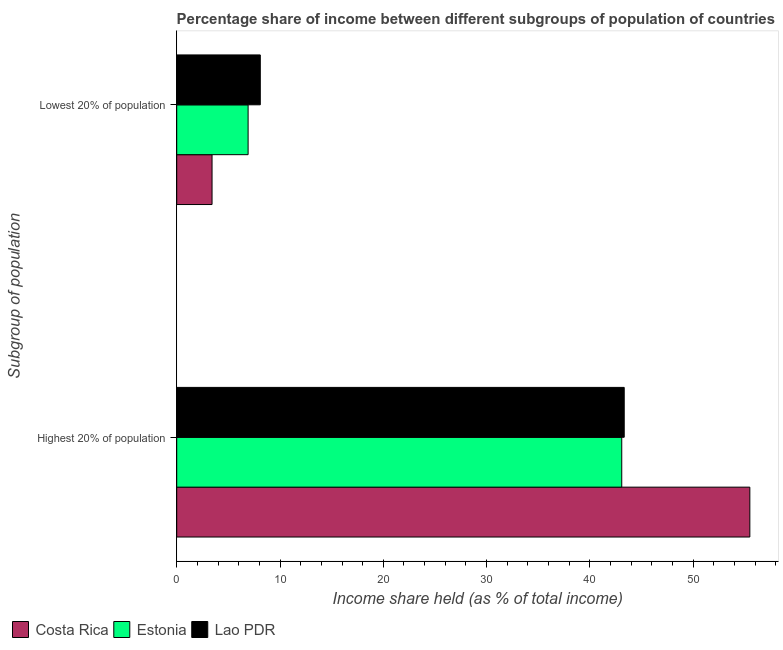Are the number of bars on each tick of the Y-axis equal?
Provide a succinct answer. Yes. How many bars are there on the 1st tick from the top?
Your answer should be compact. 3. What is the label of the 2nd group of bars from the top?
Make the answer very short. Highest 20% of population. What is the income share held by highest 20% of the population in Estonia?
Make the answer very short. 43.08. Across all countries, what is the maximum income share held by highest 20% of the population?
Provide a short and direct response. 55.48. Across all countries, what is the minimum income share held by highest 20% of the population?
Your answer should be very brief. 43.08. In which country was the income share held by highest 20% of the population maximum?
Your answer should be compact. Costa Rica. In which country was the income share held by lowest 20% of the population minimum?
Offer a very short reply. Costa Rica. What is the total income share held by lowest 20% of the population in the graph?
Make the answer very short. 18.42. What is the difference between the income share held by highest 20% of the population in Lao PDR and that in Costa Rica?
Your answer should be very brief. -12.16. What is the difference between the income share held by lowest 20% of the population in Lao PDR and the income share held by highest 20% of the population in Estonia?
Provide a short and direct response. -34.99. What is the average income share held by highest 20% of the population per country?
Your response must be concise. 47.29. What is the difference between the income share held by lowest 20% of the population and income share held by highest 20% of the population in Lao PDR?
Ensure brevity in your answer.  -35.23. In how many countries, is the income share held by highest 20% of the population greater than 48 %?
Give a very brief answer. 1. What is the ratio of the income share held by lowest 20% of the population in Estonia to that in Lao PDR?
Offer a terse response. 0.85. Is the income share held by highest 20% of the population in Lao PDR less than that in Estonia?
Offer a very short reply. No. In how many countries, is the income share held by lowest 20% of the population greater than the average income share held by lowest 20% of the population taken over all countries?
Keep it short and to the point. 2. What does the 1st bar from the top in Highest 20% of population represents?
Provide a succinct answer. Lao PDR. What does the 3rd bar from the bottom in Highest 20% of population represents?
Ensure brevity in your answer.  Lao PDR. How many bars are there?
Offer a terse response. 6. Are all the bars in the graph horizontal?
Your response must be concise. Yes. Are the values on the major ticks of X-axis written in scientific E-notation?
Make the answer very short. No. Does the graph contain any zero values?
Offer a terse response. No. Does the graph contain grids?
Make the answer very short. No. What is the title of the graph?
Give a very brief answer. Percentage share of income between different subgroups of population of countries. Does "Congo (Republic)" appear as one of the legend labels in the graph?
Keep it short and to the point. No. What is the label or title of the X-axis?
Provide a short and direct response. Income share held (as % of total income). What is the label or title of the Y-axis?
Ensure brevity in your answer.  Subgroup of population. What is the Income share held (as % of total income) of Costa Rica in Highest 20% of population?
Give a very brief answer. 55.48. What is the Income share held (as % of total income) in Estonia in Highest 20% of population?
Ensure brevity in your answer.  43.08. What is the Income share held (as % of total income) in Lao PDR in Highest 20% of population?
Your answer should be very brief. 43.32. What is the Income share held (as % of total income) of Costa Rica in Lowest 20% of population?
Provide a succinct answer. 3.42. What is the Income share held (as % of total income) in Estonia in Lowest 20% of population?
Offer a very short reply. 6.91. What is the Income share held (as % of total income) in Lao PDR in Lowest 20% of population?
Provide a short and direct response. 8.09. Across all Subgroup of population, what is the maximum Income share held (as % of total income) of Costa Rica?
Offer a terse response. 55.48. Across all Subgroup of population, what is the maximum Income share held (as % of total income) of Estonia?
Offer a very short reply. 43.08. Across all Subgroup of population, what is the maximum Income share held (as % of total income) of Lao PDR?
Make the answer very short. 43.32. Across all Subgroup of population, what is the minimum Income share held (as % of total income) in Costa Rica?
Your response must be concise. 3.42. Across all Subgroup of population, what is the minimum Income share held (as % of total income) in Estonia?
Ensure brevity in your answer.  6.91. Across all Subgroup of population, what is the minimum Income share held (as % of total income) of Lao PDR?
Keep it short and to the point. 8.09. What is the total Income share held (as % of total income) in Costa Rica in the graph?
Your answer should be very brief. 58.9. What is the total Income share held (as % of total income) in Estonia in the graph?
Your response must be concise. 49.99. What is the total Income share held (as % of total income) in Lao PDR in the graph?
Your response must be concise. 51.41. What is the difference between the Income share held (as % of total income) of Costa Rica in Highest 20% of population and that in Lowest 20% of population?
Give a very brief answer. 52.06. What is the difference between the Income share held (as % of total income) in Estonia in Highest 20% of population and that in Lowest 20% of population?
Offer a very short reply. 36.17. What is the difference between the Income share held (as % of total income) in Lao PDR in Highest 20% of population and that in Lowest 20% of population?
Your answer should be very brief. 35.23. What is the difference between the Income share held (as % of total income) of Costa Rica in Highest 20% of population and the Income share held (as % of total income) of Estonia in Lowest 20% of population?
Your answer should be very brief. 48.57. What is the difference between the Income share held (as % of total income) in Costa Rica in Highest 20% of population and the Income share held (as % of total income) in Lao PDR in Lowest 20% of population?
Offer a very short reply. 47.39. What is the difference between the Income share held (as % of total income) of Estonia in Highest 20% of population and the Income share held (as % of total income) of Lao PDR in Lowest 20% of population?
Offer a very short reply. 34.99. What is the average Income share held (as % of total income) in Costa Rica per Subgroup of population?
Ensure brevity in your answer.  29.45. What is the average Income share held (as % of total income) in Estonia per Subgroup of population?
Your response must be concise. 25. What is the average Income share held (as % of total income) in Lao PDR per Subgroup of population?
Provide a short and direct response. 25.7. What is the difference between the Income share held (as % of total income) in Costa Rica and Income share held (as % of total income) in Estonia in Highest 20% of population?
Make the answer very short. 12.4. What is the difference between the Income share held (as % of total income) in Costa Rica and Income share held (as % of total income) in Lao PDR in Highest 20% of population?
Your response must be concise. 12.16. What is the difference between the Income share held (as % of total income) of Estonia and Income share held (as % of total income) of Lao PDR in Highest 20% of population?
Your response must be concise. -0.24. What is the difference between the Income share held (as % of total income) of Costa Rica and Income share held (as % of total income) of Estonia in Lowest 20% of population?
Keep it short and to the point. -3.49. What is the difference between the Income share held (as % of total income) of Costa Rica and Income share held (as % of total income) of Lao PDR in Lowest 20% of population?
Your answer should be compact. -4.67. What is the difference between the Income share held (as % of total income) of Estonia and Income share held (as % of total income) of Lao PDR in Lowest 20% of population?
Your answer should be compact. -1.18. What is the ratio of the Income share held (as % of total income) of Costa Rica in Highest 20% of population to that in Lowest 20% of population?
Keep it short and to the point. 16.22. What is the ratio of the Income share held (as % of total income) of Estonia in Highest 20% of population to that in Lowest 20% of population?
Make the answer very short. 6.23. What is the ratio of the Income share held (as % of total income) of Lao PDR in Highest 20% of population to that in Lowest 20% of population?
Your response must be concise. 5.35. What is the difference between the highest and the second highest Income share held (as % of total income) in Costa Rica?
Your answer should be compact. 52.06. What is the difference between the highest and the second highest Income share held (as % of total income) of Estonia?
Your answer should be compact. 36.17. What is the difference between the highest and the second highest Income share held (as % of total income) in Lao PDR?
Make the answer very short. 35.23. What is the difference between the highest and the lowest Income share held (as % of total income) of Costa Rica?
Your answer should be compact. 52.06. What is the difference between the highest and the lowest Income share held (as % of total income) in Estonia?
Your answer should be compact. 36.17. What is the difference between the highest and the lowest Income share held (as % of total income) in Lao PDR?
Provide a succinct answer. 35.23. 